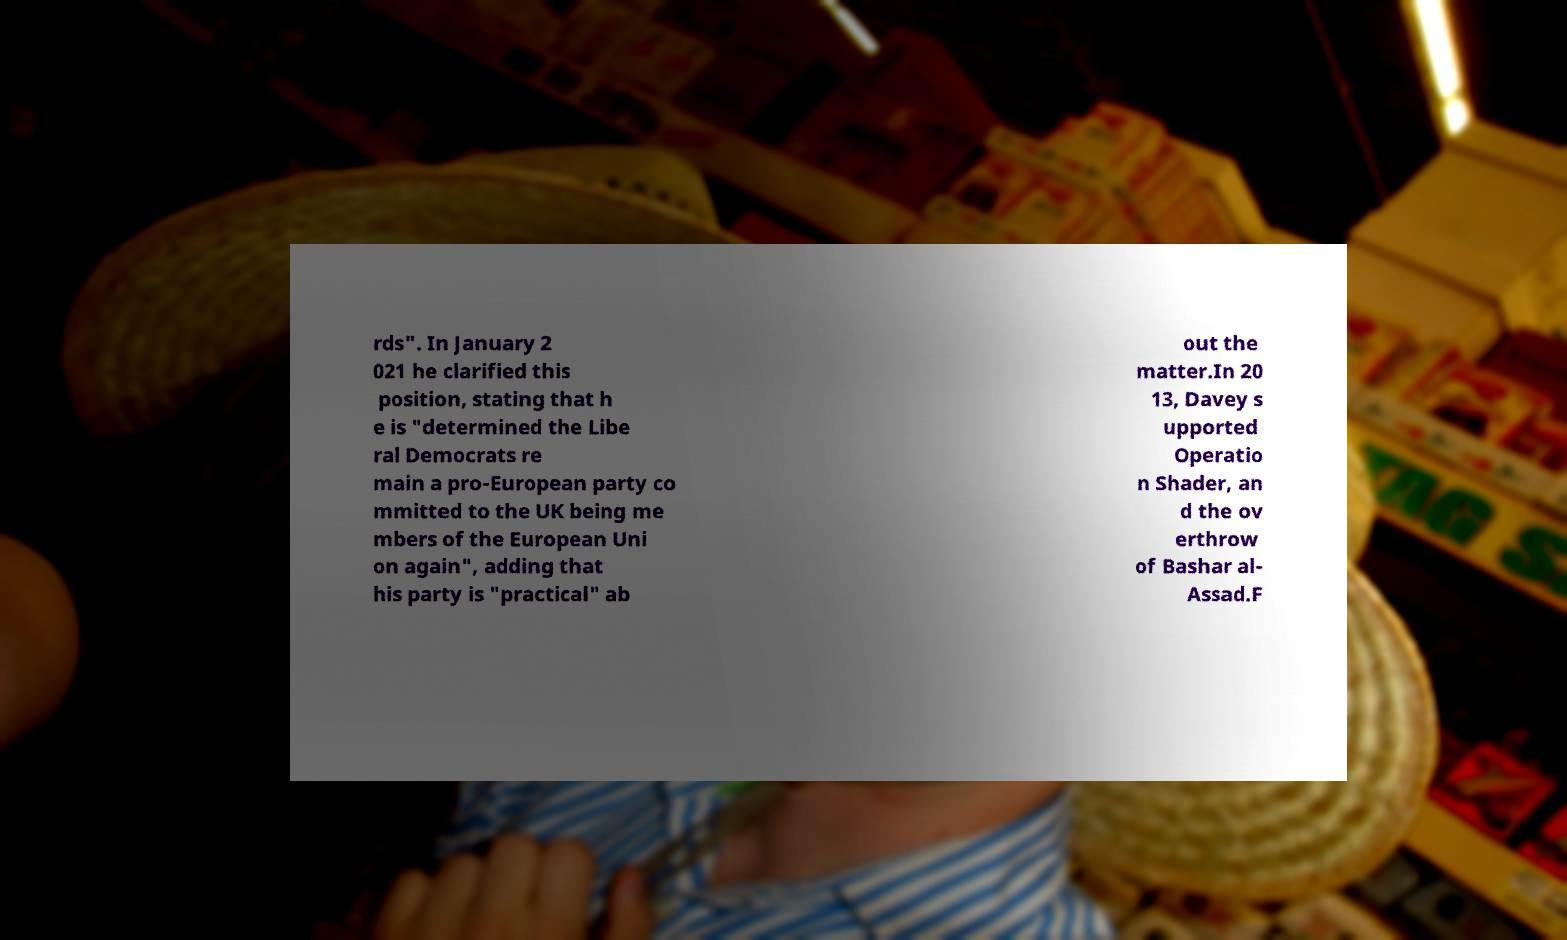What messages or text are displayed in this image? I need them in a readable, typed format. rds". In January 2 021 he clarified this position, stating that h e is "determined the Libe ral Democrats re main a pro-European party co mmitted to the UK being me mbers of the European Uni on again", adding that his party is "practical" ab out the matter.In 20 13, Davey s upported Operatio n Shader, an d the ov erthrow of Bashar al- Assad.F 